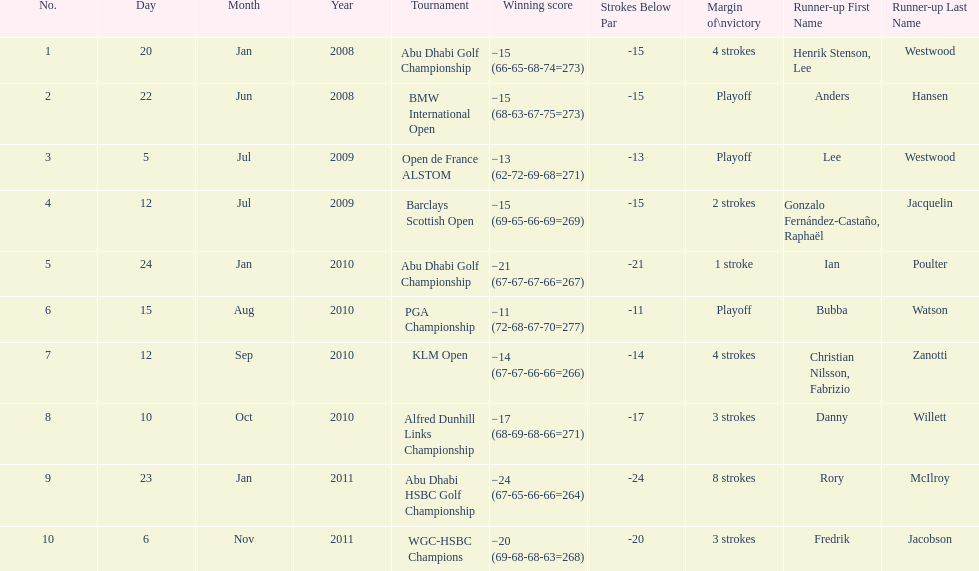How many total tournaments has he won? 10. 